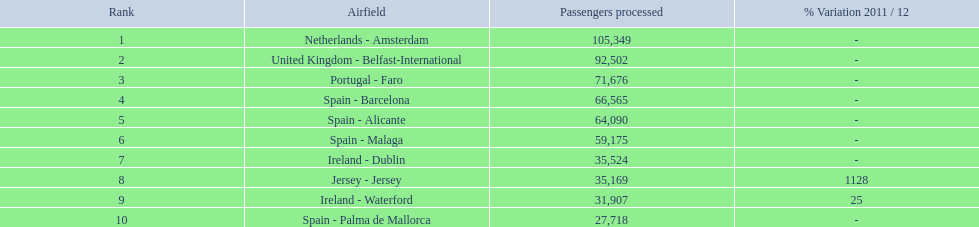What are the names of all the airports? Netherlands - Amsterdam, United Kingdom - Belfast-International, Portugal - Faro, Spain - Barcelona, Spain - Alicante, Spain - Malaga, Ireland - Dublin, Jersey - Jersey, Ireland - Waterford, Spain - Palma de Mallorca. Of these, what are all the passenger counts? 105,349, 92,502, 71,676, 66,565, 64,090, 59,175, 35,524, 35,169, 31,907, 27,718. Of these, which airport had more passengers than the united kingdom? Netherlands - Amsterdam. 